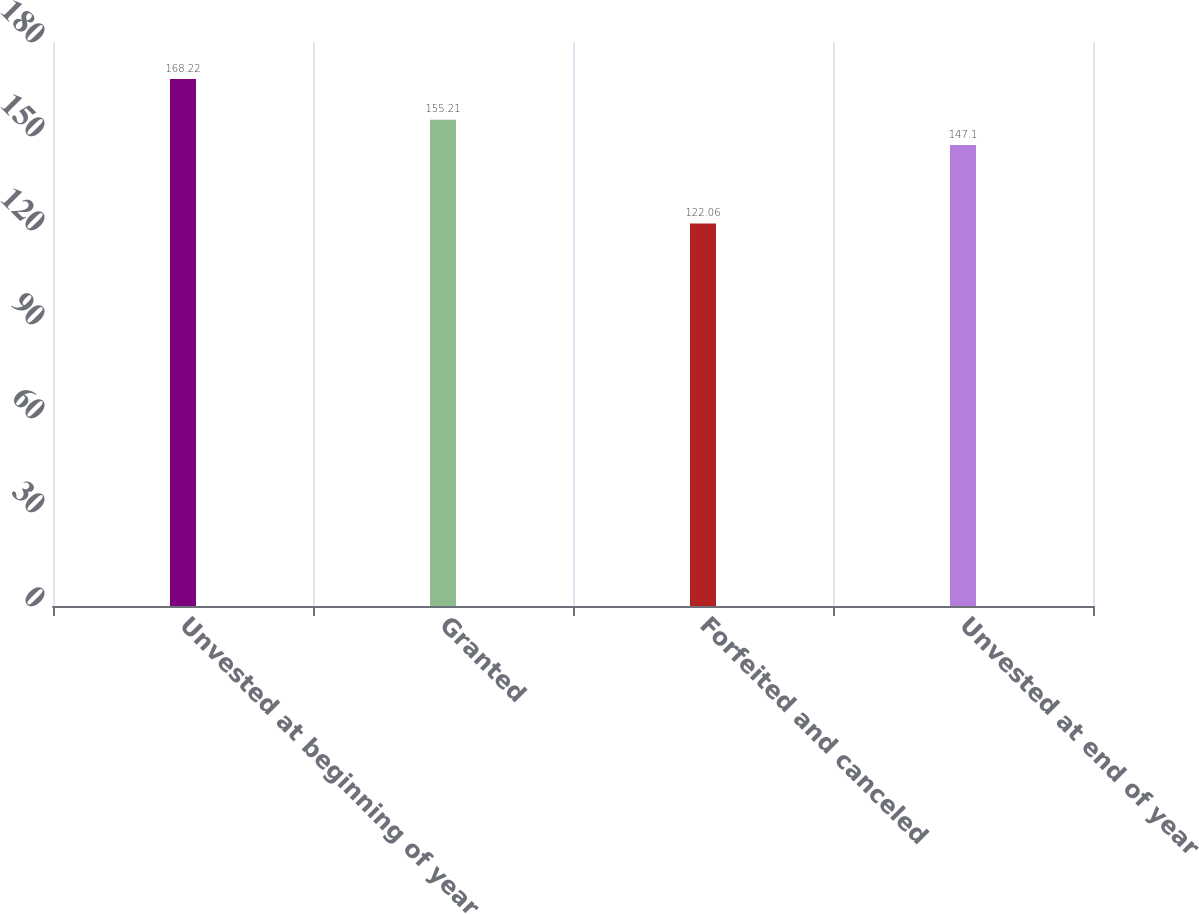Convert chart. <chart><loc_0><loc_0><loc_500><loc_500><bar_chart><fcel>Unvested at beginning of year<fcel>Granted<fcel>Forfeited and canceled<fcel>Unvested at end of year<nl><fcel>168.22<fcel>155.21<fcel>122.06<fcel>147.1<nl></chart> 